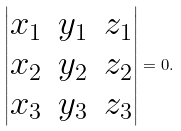<formula> <loc_0><loc_0><loc_500><loc_500>\left | \begin{matrix} x _ { 1 } & y _ { 1 } & z _ { 1 } \\ x _ { 2 } & y _ { 2 } & z _ { 2 } \\ x _ { 3 } & y _ { 3 } & z _ { 3 } \end{matrix} \right | = 0 .</formula> 